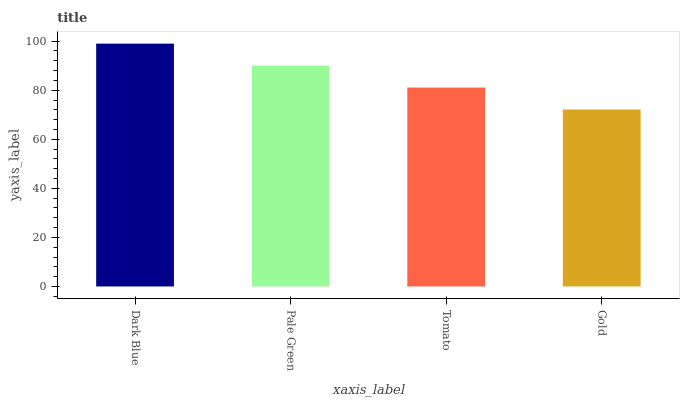Is Gold the minimum?
Answer yes or no. Yes. Is Dark Blue the maximum?
Answer yes or no. Yes. Is Pale Green the minimum?
Answer yes or no. No. Is Pale Green the maximum?
Answer yes or no. No. Is Dark Blue greater than Pale Green?
Answer yes or no. Yes. Is Pale Green less than Dark Blue?
Answer yes or no. Yes. Is Pale Green greater than Dark Blue?
Answer yes or no. No. Is Dark Blue less than Pale Green?
Answer yes or no. No. Is Pale Green the high median?
Answer yes or no. Yes. Is Tomato the low median?
Answer yes or no. Yes. Is Tomato the high median?
Answer yes or no. No. Is Dark Blue the low median?
Answer yes or no. No. 